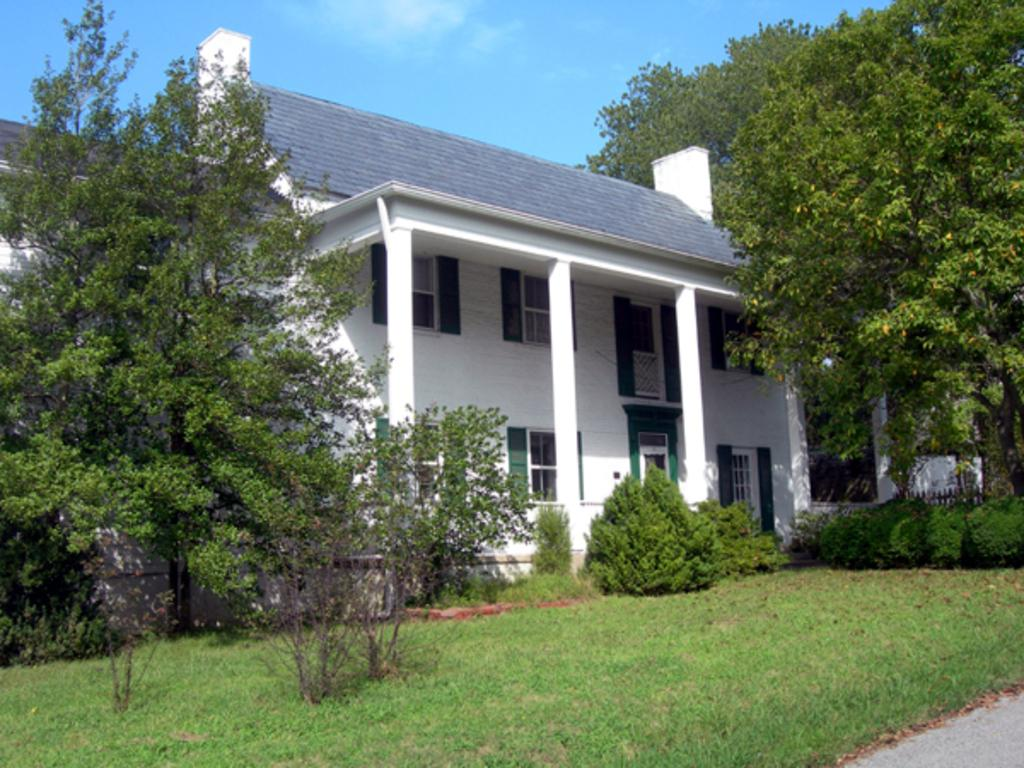What is the main subject of the image? There is a building at the center of the image. What can be seen in front of the building? There are trees, plants, and grass in front of the building. What is visible in the background of the image? The sky is visible in the background of the image. What type of comb is being used to trim the plants in the image? There is no comb present in the image, nor is there any indication that the plants are being trimmed. 